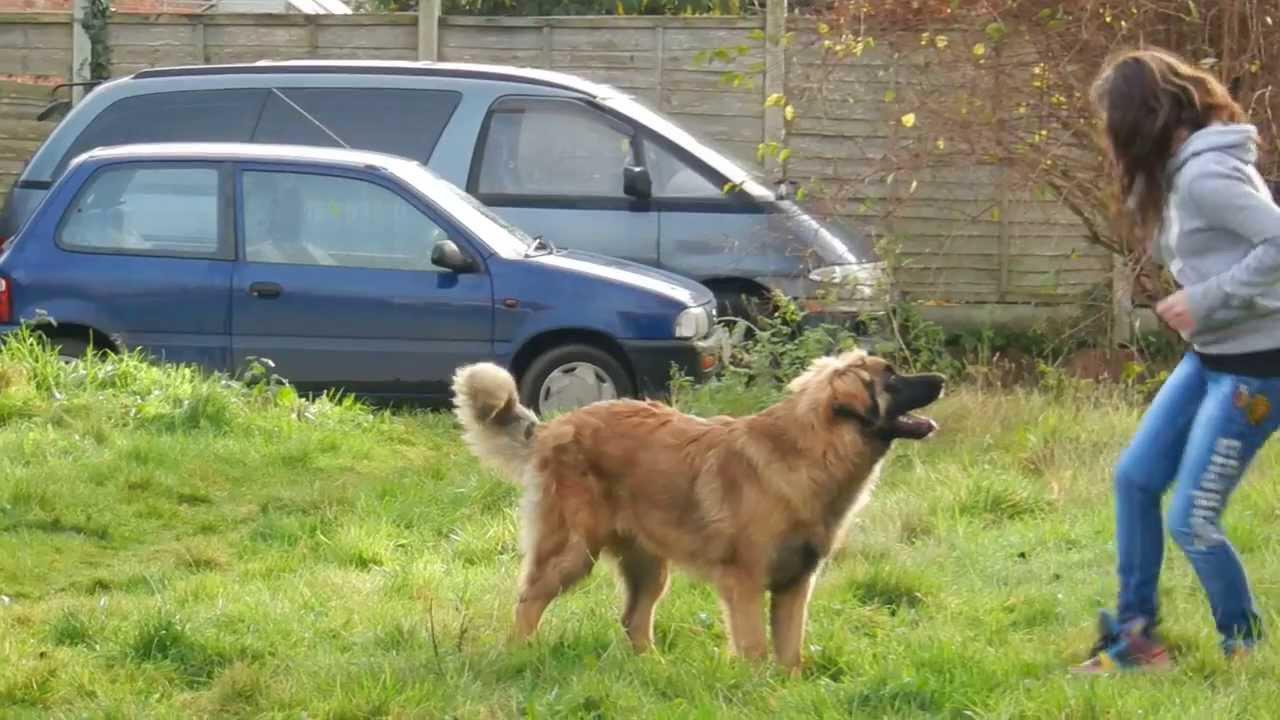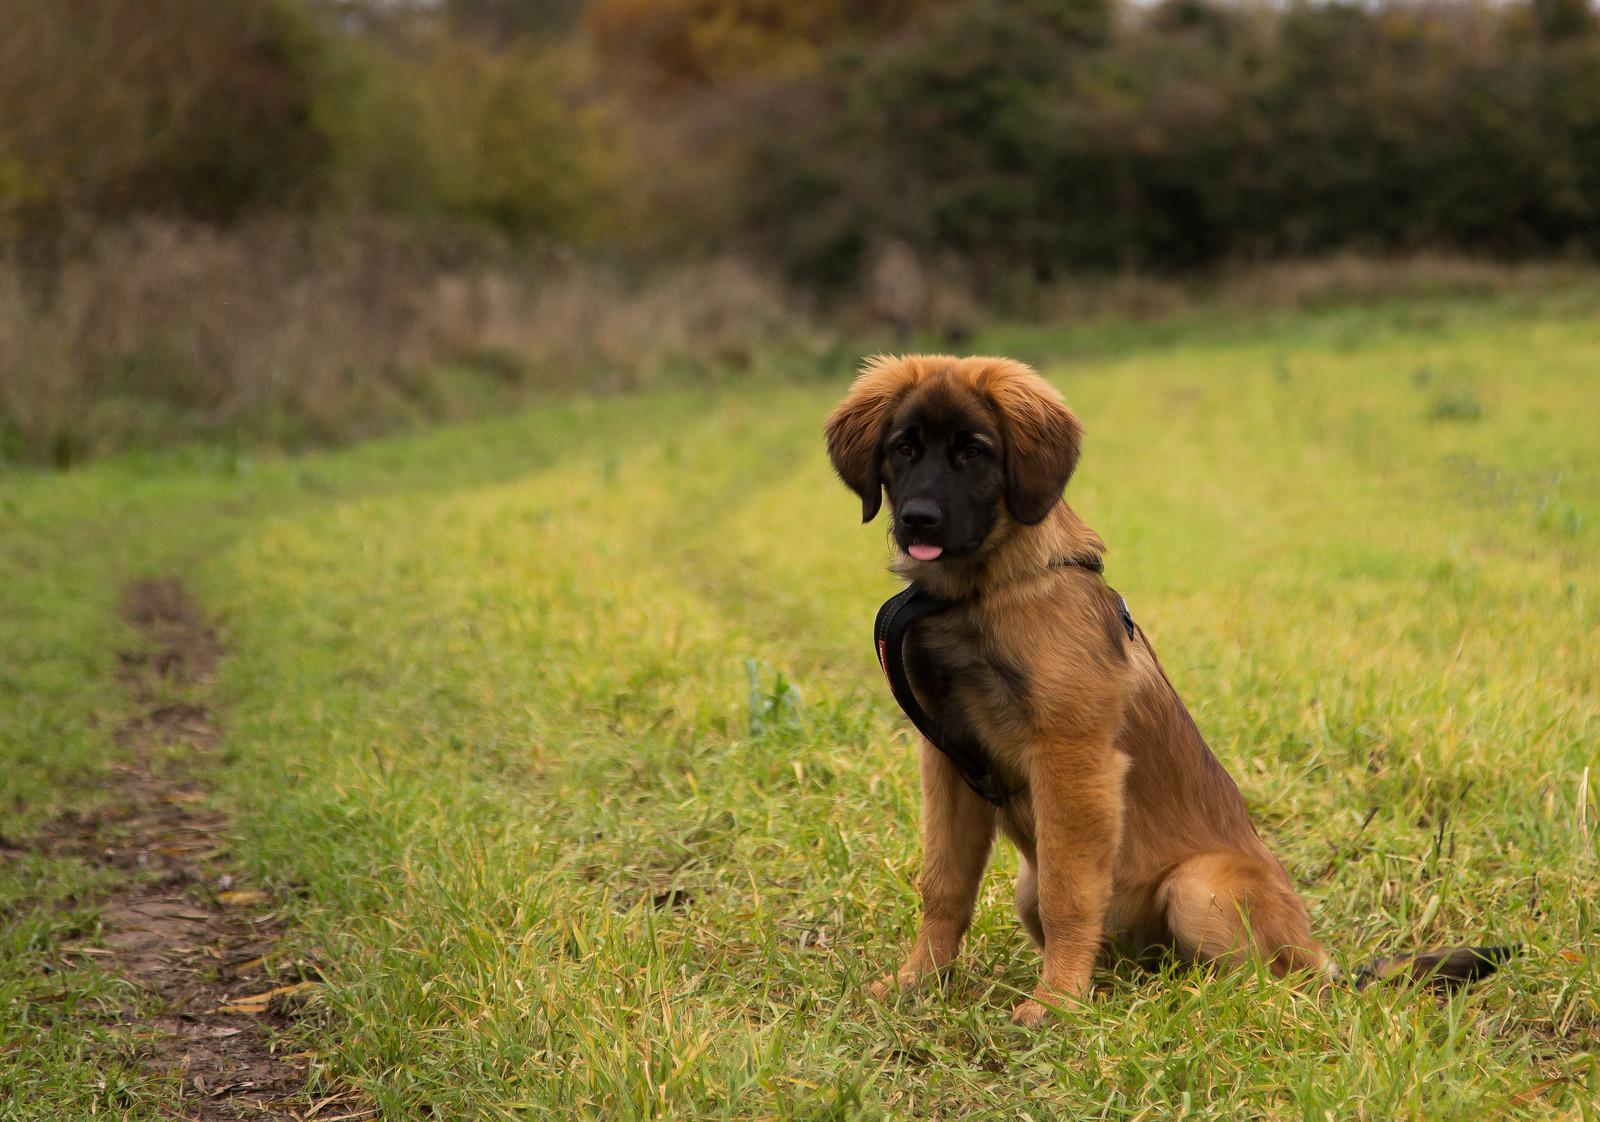The first image is the image on the left, the second image is the image on the right. Analyze the images presented: Is the assertion "Only one dog is sitting in the grass." valid? Answer yes or no. Yes. The first image is the image on the left, the second image is the image on the right. Assess this claim about the two images: "two puppies are atanding next to each other on the grass looking upward". Correct or not? Answer yes or no. No. 